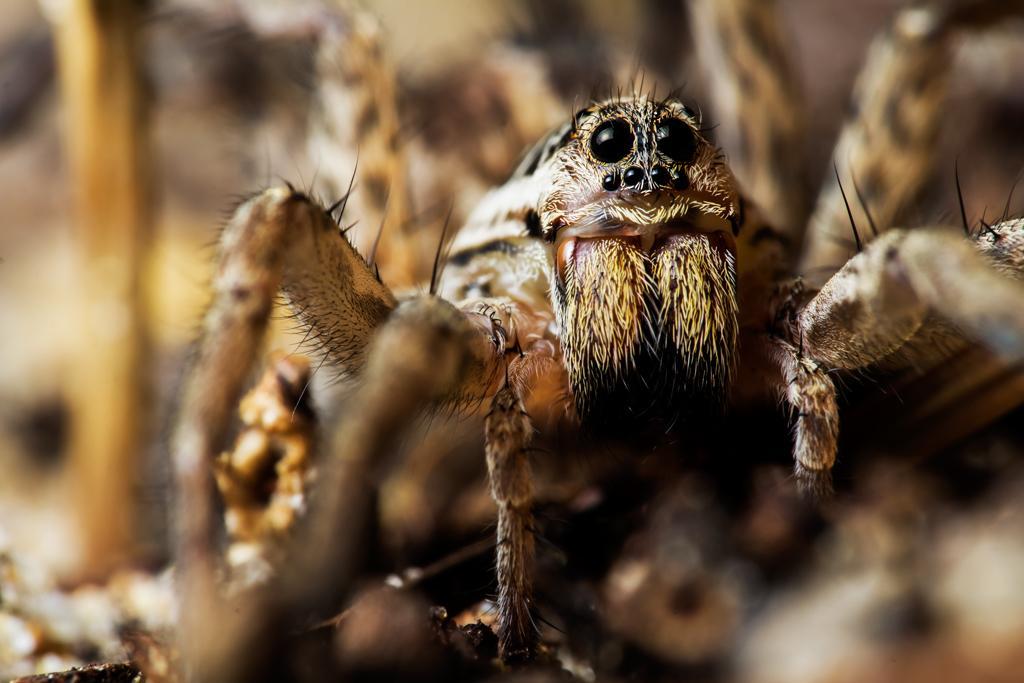Please provide a concise description of this image. In this image this looks like a spider. The background looks blurry. 